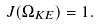<formula> <loc_0><loc_0><loc_500><loc_500>J ( \Omega _ { K E } ) = 1 .</formula> 